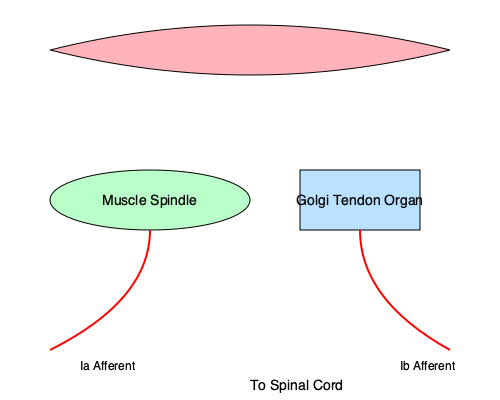Analyze the diagram and explain how the muscle spindle and Golgi tendon organ contribute to proprioception. What are the key differences in their functions, and how do their respective afferent neurons (Ia and Ib) relay information to the central nervous system? 1. Muscle Spindles:
   - Located within the muscle belly
   - Function: Detect changes in muscle length and rate of length change
   - Innervated by Ia afferent neurons
   - Respond to both static and dynamic stretch

2. Golgi Tendon Organs:
   - Located at the muscle-tendon junction
   - Function: Detect changes in muscle tension
   - Innervated by Ib afferent neurons
   - Respond primarily to active muscle contraction

3. Proprioceptive Information:
   - Muscle spindles provide information about muscle length and velocity
   - Golgi tendon organs provide information about muscle force

4. Afferent Pathways:
   - Ia afferents (from muscle spindles):
     a. Enter the spinal cord through dorsal root ganglia
     b. Form monosynaptic connections with alpha motor neurons
     c. Also project to higher centers (cerebellum, cortex) for conscious proprioception
   - Ib afferents (from Golgi tendon organs):
     a. Enter the spinal cord through dorsal root ganglia
     b. Form polysynaptic connections with interneurons
     c. Contribute to force perception and motor control

5. Integration:
   - The central nervous system integrates information from both receptors
   - This integration allows for precise control of movement and posture
   - Contributes to both reflex actions and conscious proprioception

6. Clinical Significance:
   - Damage to these pathways can result in impaired proprioception
   - This can lead to difficulties in coordination, balance, and fine motor control
Answer: Muscle spindles detect muscle length changes via Ia afferents, while Golgi tendon organs sense muscle tension through Ib afferents. Both contribute to proprioception by relaying information to the spinal cord and higher centers, enabling precise motor control and conscious awareness of body position. 